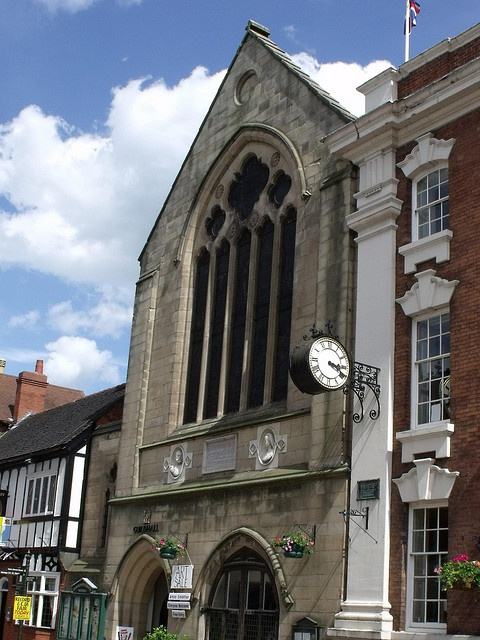Describe the objects in this image and their specific colors. I can see clock in gray, black, white, and darkgray tones, potted plant in gray, black, darkgreen, and maroon tones, potted plant in gray, black, and darkgreen tones, and potted plant in gray, black, and darkgreen tones in this image. 